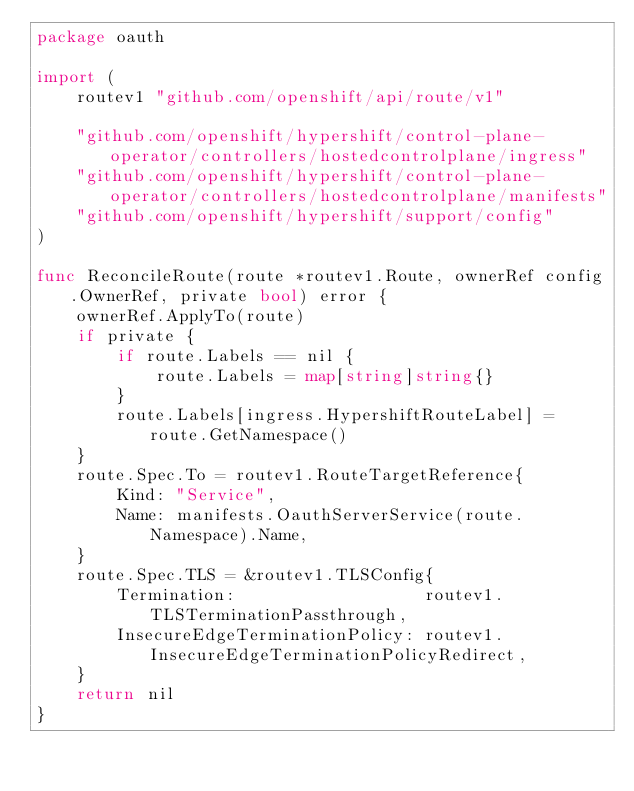<code> <loc_0><loc_0><loc_500><loc_500><_Go_>package oauth

import (
	routev1 "github.com/openshift/api/route/v1"

	"github.com/openshift/hypershift/control-plane-operator/controllers/hostedcontrolplane/ingress"
	"github.com/openshift/hypershift/control-plane-operator/controllers/hostedcontrolplane/manifests"
	"github.com/openshift/hypershift/support/config"
)

func ReconcileRoute(route *routev1.Route, ownerRef config.OwnerRef, private bool) error {
	ownerRef.ApplyTo(route)
	if private {
		if route.Labels == nil {
			route.Labels = map[string]string{}
		}
		route.Labels[ingress.HypershiftRouteLabel] = route.GetNamespace()
	}
	route.Spec.To = routev1.RouteTargetReference{
		Kind: "Service",
		Name: manifests.OauthServerService(route.Namespace).Name,
	}
	route.Spec.TLS = &routev1.TLSConfig{
		Termination:                   routev1.TLSTerminationPassthrough,
		InsecureEdgeTerminationPolicy: routev1.InsecureEdgeTerminationPolicyRedirect,
	}
	return nil
}
</code> 